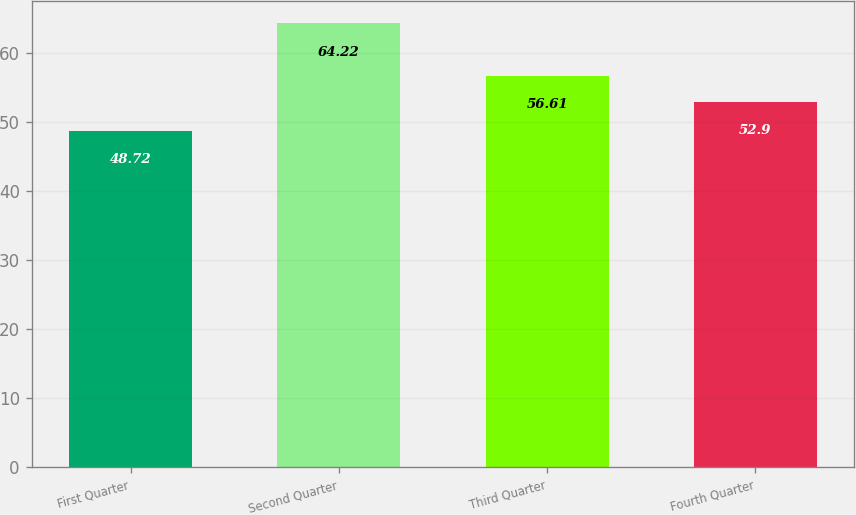<chart> <loc_0><loc_0><loc_500><loc_500><bar_chart><fcel>First Quarter<fcel>Second Quarter<fcel>Third Quarter<fcel>Fourth Quarter<nl><fcel>48.72<fcel>64.22<fcel>56.61<fcel>52.9<nl></chart> 